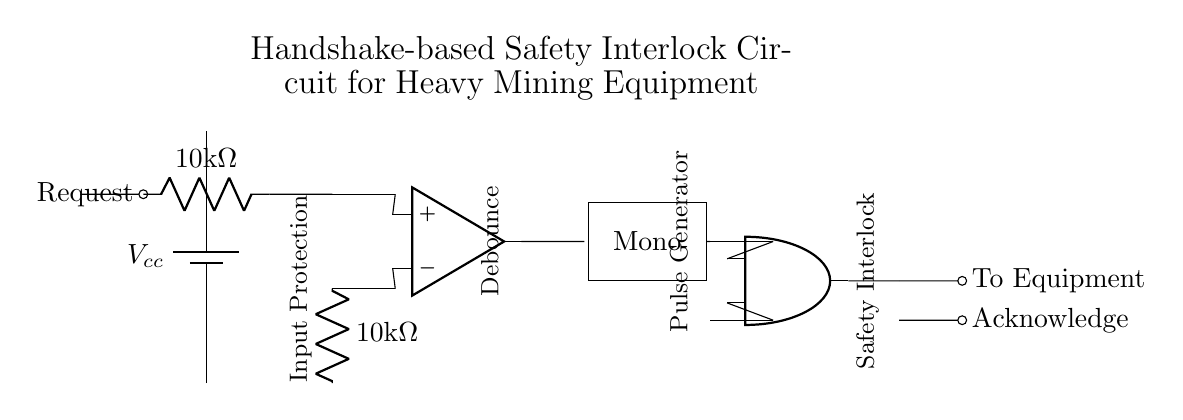What is the voltage supply represented in the circuit? The circuit shows a voltage supply labeled as Vcc, which usually indicates the positive voltage supply connected to the circuit components.
Answer: Vcc What is the resistance value of the resistors in the input logic? The circuit diagram shows two resistors in the input logic, both labeled as 10kΩ, indicating they each have a resistance of ten thousand ohms.
Answer: 10kΩ What type of logic gate is used in the circuit? The circuit includes an AND gate, specifically indicated by the symbol for the AND port, which is used to perform logical multiplication of the input signals.
Answer: AND What component is used for debouncing the input signal? The circuit includes a Schmitt trigger, which is specifically used for debouncing input signals to ensure clean switching and avoid false triggering.
Answer: Schmitt trigger How many main sections are there in this handshake-based interlock circuit? The circuit can be divided into four main sections: input protection (resistors), debounce (Schmitt trigger), pulse generator (monostable multivibrator), and safety interlock (AND gate).
Answer: Four What indicates the output of the safety interlock to the equipment? The output of the safety interlock is represented by a line connecting from the AND gate's output to a labeled point that says "To Equipment," showing where the control signal is directed.
Answer: To Equipment What purpose does the monostable multivibrator serve in this circuit? The monostable multivibrator generates a pulse in response to the input signal, ensuring a temporary output for the required duration, acting as a timer in the circuit's operation.
Answer: Pulse generator 